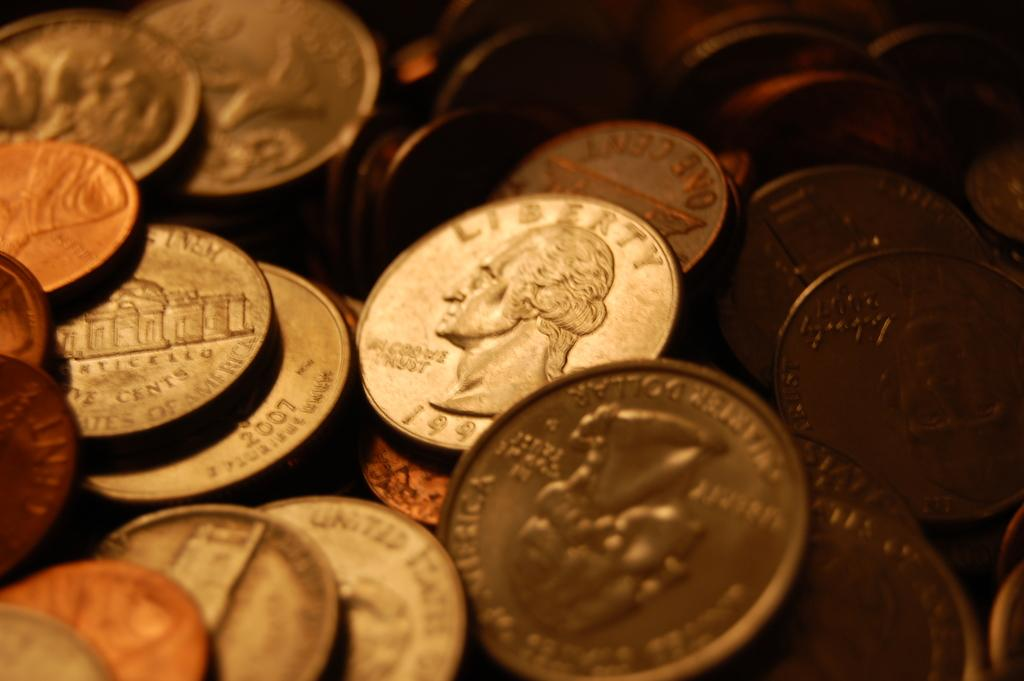<image>
Offer a succinct explanation of the picture presented. A pile of coins, one with the word liberty on it another the whitehouse. 